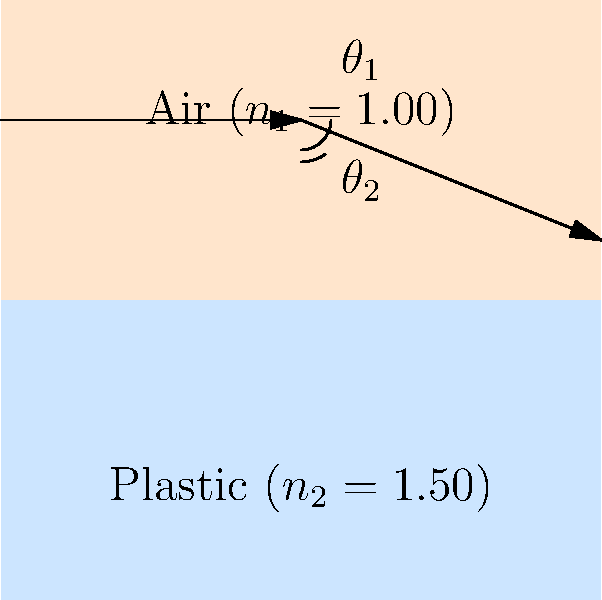In designing a clear product display case, you're considering the refraction of light through different mediums. A light ray passes from air ($n_1 = 1.00$) into a plastic material ($n_2 = 1.50$) at an angle of incidence $\theta_1 = 30°$. Using Snell's law, calculate the angle of refraction $\theta_2$ inside the plastic. How might this affect the visibility of products inside the case? To solve this problem, we'll use Snell's law and follow these steps:

1. Recall Snell's law: $n_1 \sin(\theta_1) = n_2 \sin(\theta_2)$

2. We know:
   - $n_1 = 1.00$ (air)
   - $n_2 = 1.50$ (plastic)
   - $\theta_1 = 30°$

3. Substitute these values into Snell's law:
   $1.00 \sin(30°) = 1.50 \sin(\theta_2)$

4. Simplify the left side:
   $0.5 = 1.50 \sin(\theta_2)$

5. Solve for $\sin(\theta_2)$:
   $\sin(\theta_2) = \frac{0.5}{1.50} = \frac{1}{3}$

6. Take the inverse sine (arcsin) of both sides:
   $\theta_2 = \arcsin(\frac{1}{3}) \approx 19.47°$

7. Round to two decimal places:
   $\theta_2 \approx 19.47°$

This result shows that the light ray bends towards the normal when entering the plastic from air. This refraction can affect product visibility in the following ways:

1. Reduced viewing angle: The change in angle means that light from the product will exit the case at a different angle than it entered, potentially limiting the viewing angle for customers.

2. Magnification effect: The refraction can create a slight magnification effect, making products appear larger or closer than they actually are.

3. Color dispersion: Different wavelengths of light refract at slightly different angles, which may cause some color separation or a subtle rainbow effect at the edges of products.

4. Clarity: The refractive index difference between air and plastic can lead to internal reflections, which might create glare or reduce the overall clarity of the product display.

Understanding these effects can help in designing display cases that minimize distortion and maximize product visibility.
Answer: $\theta_2 \approx 19.47°$ 